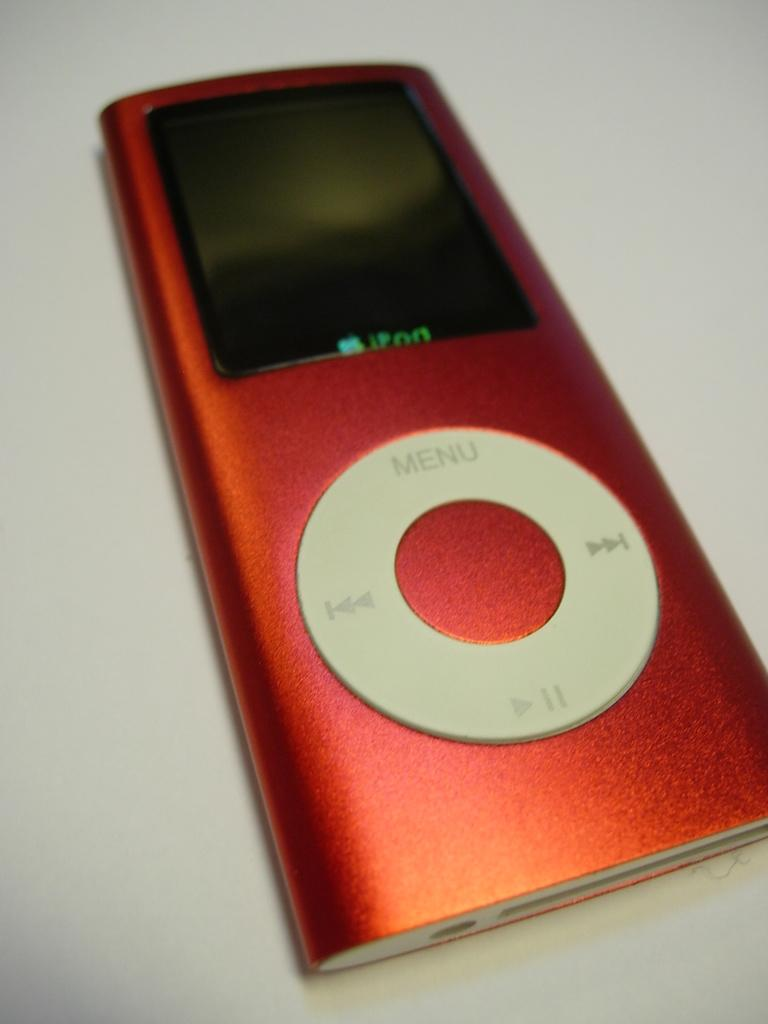What is the color of the music player in the image? The music player in the image is red-colored. What is the color of the surface on which the music player is placed? The music player is on a white-colored surface. What can be seen on the music player? There is writing on the music player. How many brothers are depicted playing the music player in the image? There are no brothers present in the image, and the music player is not being played by anyone. 